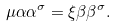<formula> <loc_0><loc_0><loc_500><loc_500>\mu \alpha \alpha ^ { \sigma } = \xi \beta \beta ^ { \sigma } .</formula> 